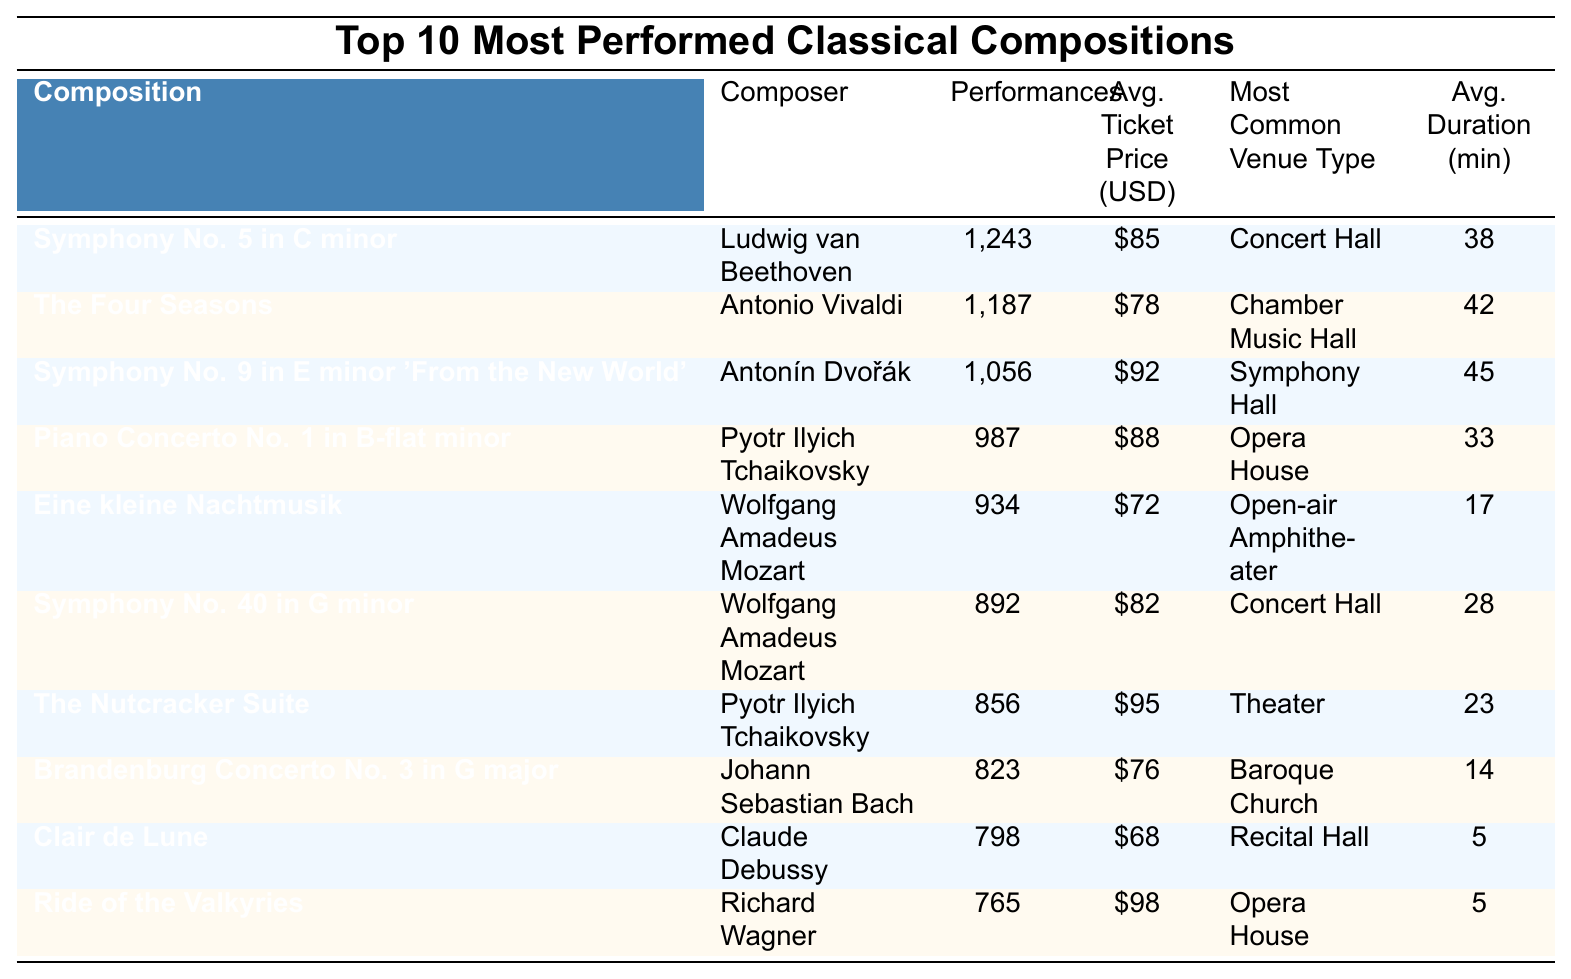What is the composition with the highest number of performances? According to the table, "Symphony No. 5 in C minor" by Ludwig van Beethoven has the highest number of performances at 1,243.
Answer: Symphony No. 5 in C minor Which composer has more compositions in the top 10 list? There are two compositions by Wolfgang Amadeus Mozart: "Eine kleine Nachtmusik" and "Symphony No. 40 in G minor". No other composer has more than one composition in the top 10 list.
Answer: Wolfgang Amadeus Mozart What is the average ticket price of the compositions by Pyotr Ilyich Tchaikovsky? The compositions by Tchaikovsky ("Piano Concerto No. 1" and "The Nutcracker Suite") have average ticket prices of $88 and $95 respectively. To find the average, we calculate: (88 + 95) / 2 = 91.5.
Answer: $91.50 Is "Ride of the Valkyries" performed more than 800 times? The table shows that "Ride of the Valkyries" has 765 performances, which is less than 800.
Answer: No What is the total number of performances for all compositions by Wolfgang Amadeus Mozart? The total performances for Mozart's compositions are calculated by adding "Eine kleine Nachtmusik" (934) and "Symphony No. 40 in G minor" (892), which results in 934 + 892 = 1,826.
Answer: 1,826 How does the average performance duration of "The Nutcracker Suite" compare to "Clair de Lune"? "The Nutcracker Suite" has an average performance duration of 23 minutes while "Clair de Lune" has an average of 5 minutes, which means "The Nutcracker Suite" is 18 minutes longer.
Answer: 18 minutes longer Which composition has the lowest average ticket price? The table shows that "Clair de Lune" has the lowest average ticket price at $68 compared to other compositions in the list.
Answer: $68 What is the most common venue type for "Symphony No. 9 in E minor 'From the New World'"? The table indicates that the most common venue type for "Symphony No. 9 in E minor 'From the New World'" is "Symphony Hall".
Answer: Symphony Hall What are the average performance durations of the two compositions by Johann Sebastian Bach? The only composition by Bach in the list is "Brandenburg Concerto No. 3 in G major", which has an average performance duration of 14 minutes. Since there's no other composition by Bach, the average is just 14 minutes.
Answer: 14 minutes Which composition performed in an Open-air Amphitheater? "Eine kleine Nachtmusik" by Wolfgang Amadeus Mozart is performed in an Open-air Amphitheater.
Answer: Eine kleine Nachtmusik 